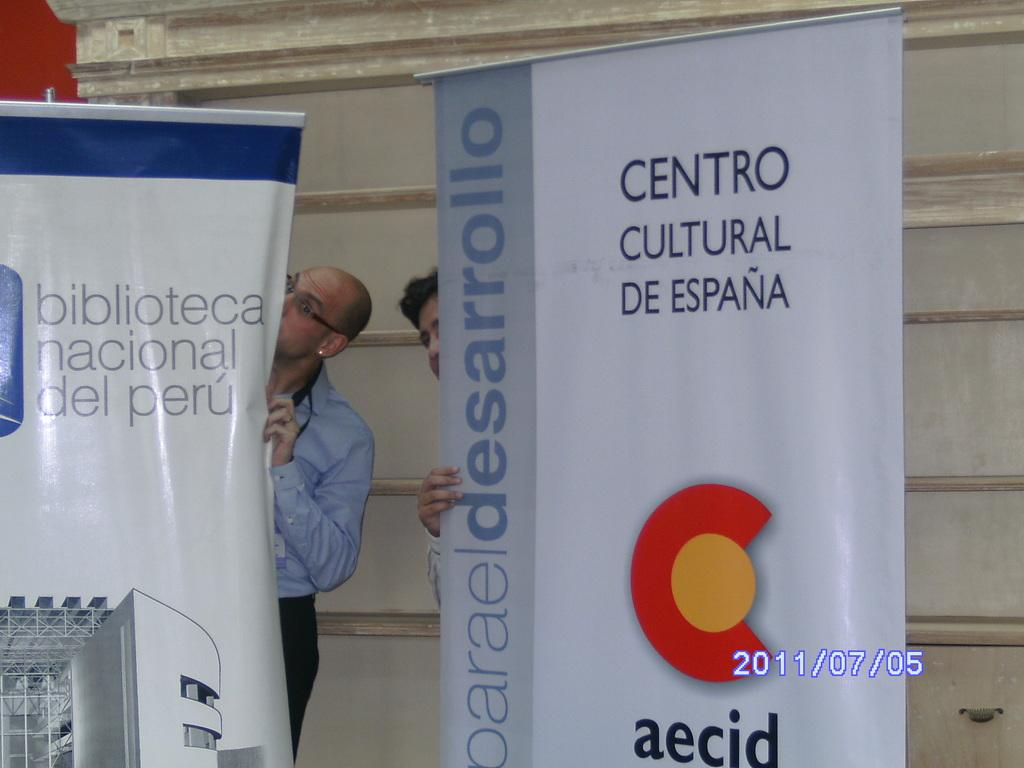Provide a one-sentence caption for the provided image. A sign that has the word centro on it. 